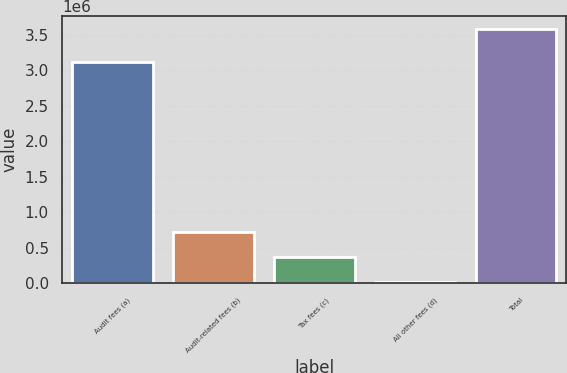Convert chart. <chart><loc_0><loc_0><loc_500><loc_500><bar_chart><fcel>Audit fees (a)<fcel>Audit-related fees (b)<fcel>Tax fees (c)<fcel>All other fees (d)<fcel>Total<nl><fcel>3.109e+06<fcel>729200<fcel>372600<fcel>16000<fcel>3.582e+06<nl></chart> 